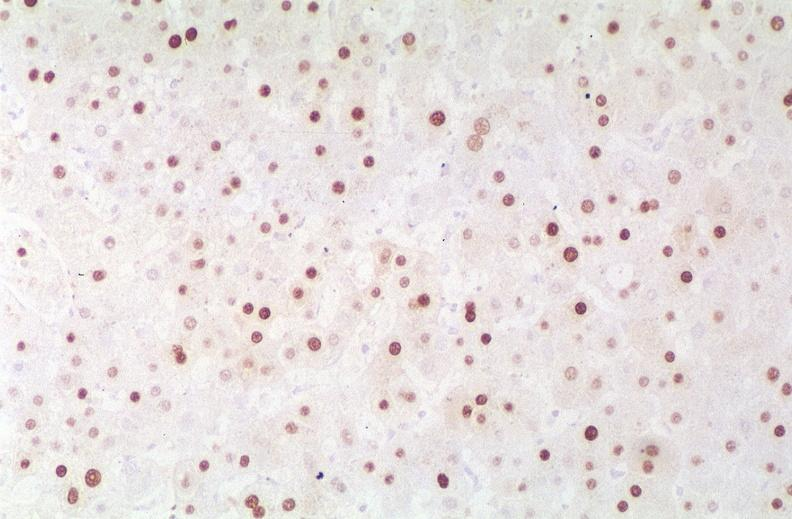what does this image show?
Answer the question using a single word or phrase. Hepatitis b virus 